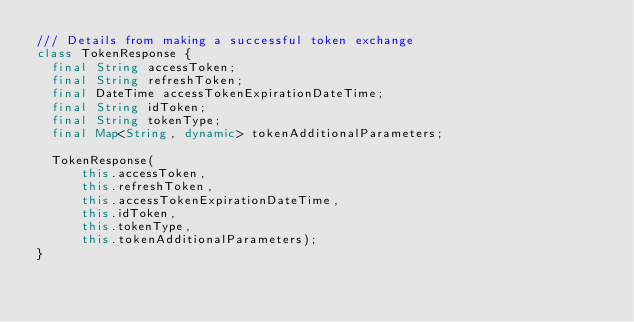Convert code to text. <code><loc_0><loc_0><loc_500><loc_500><_Dart_>/// Details from making a successful token exchange
class TokenResponse {
  final String accessToken;
  final String refreshToken;
  final DateTime accessTokenExpirationDateTime;
  final String idToken;
  final String tokenType;
  final Map<String, dynamic> tokenAdditionalParameters;

  TokenResponse(
      this.accessToken,
      this.refreshToken,
      this.accessTokenExpirationDateTime,
      this.idToken,
      this.tokenType,
      this.tokenAdditionalParameters);
}
</code> 